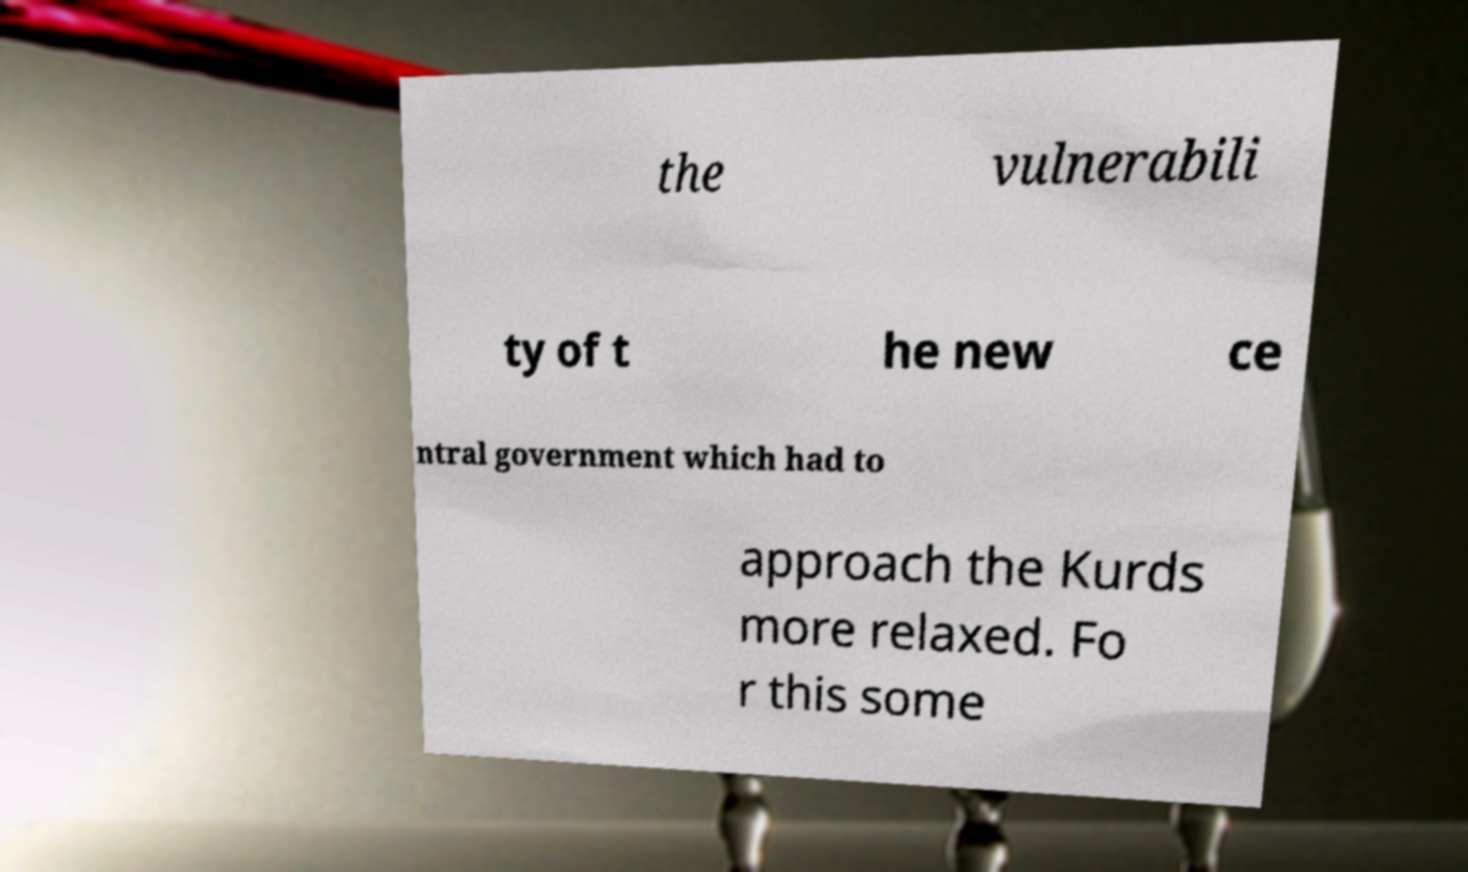Could you extract and type out the text from this image? the vulnerabili ty of t he new ce ntral government which had to approach the Kurds more relaxed. Fo r this some 